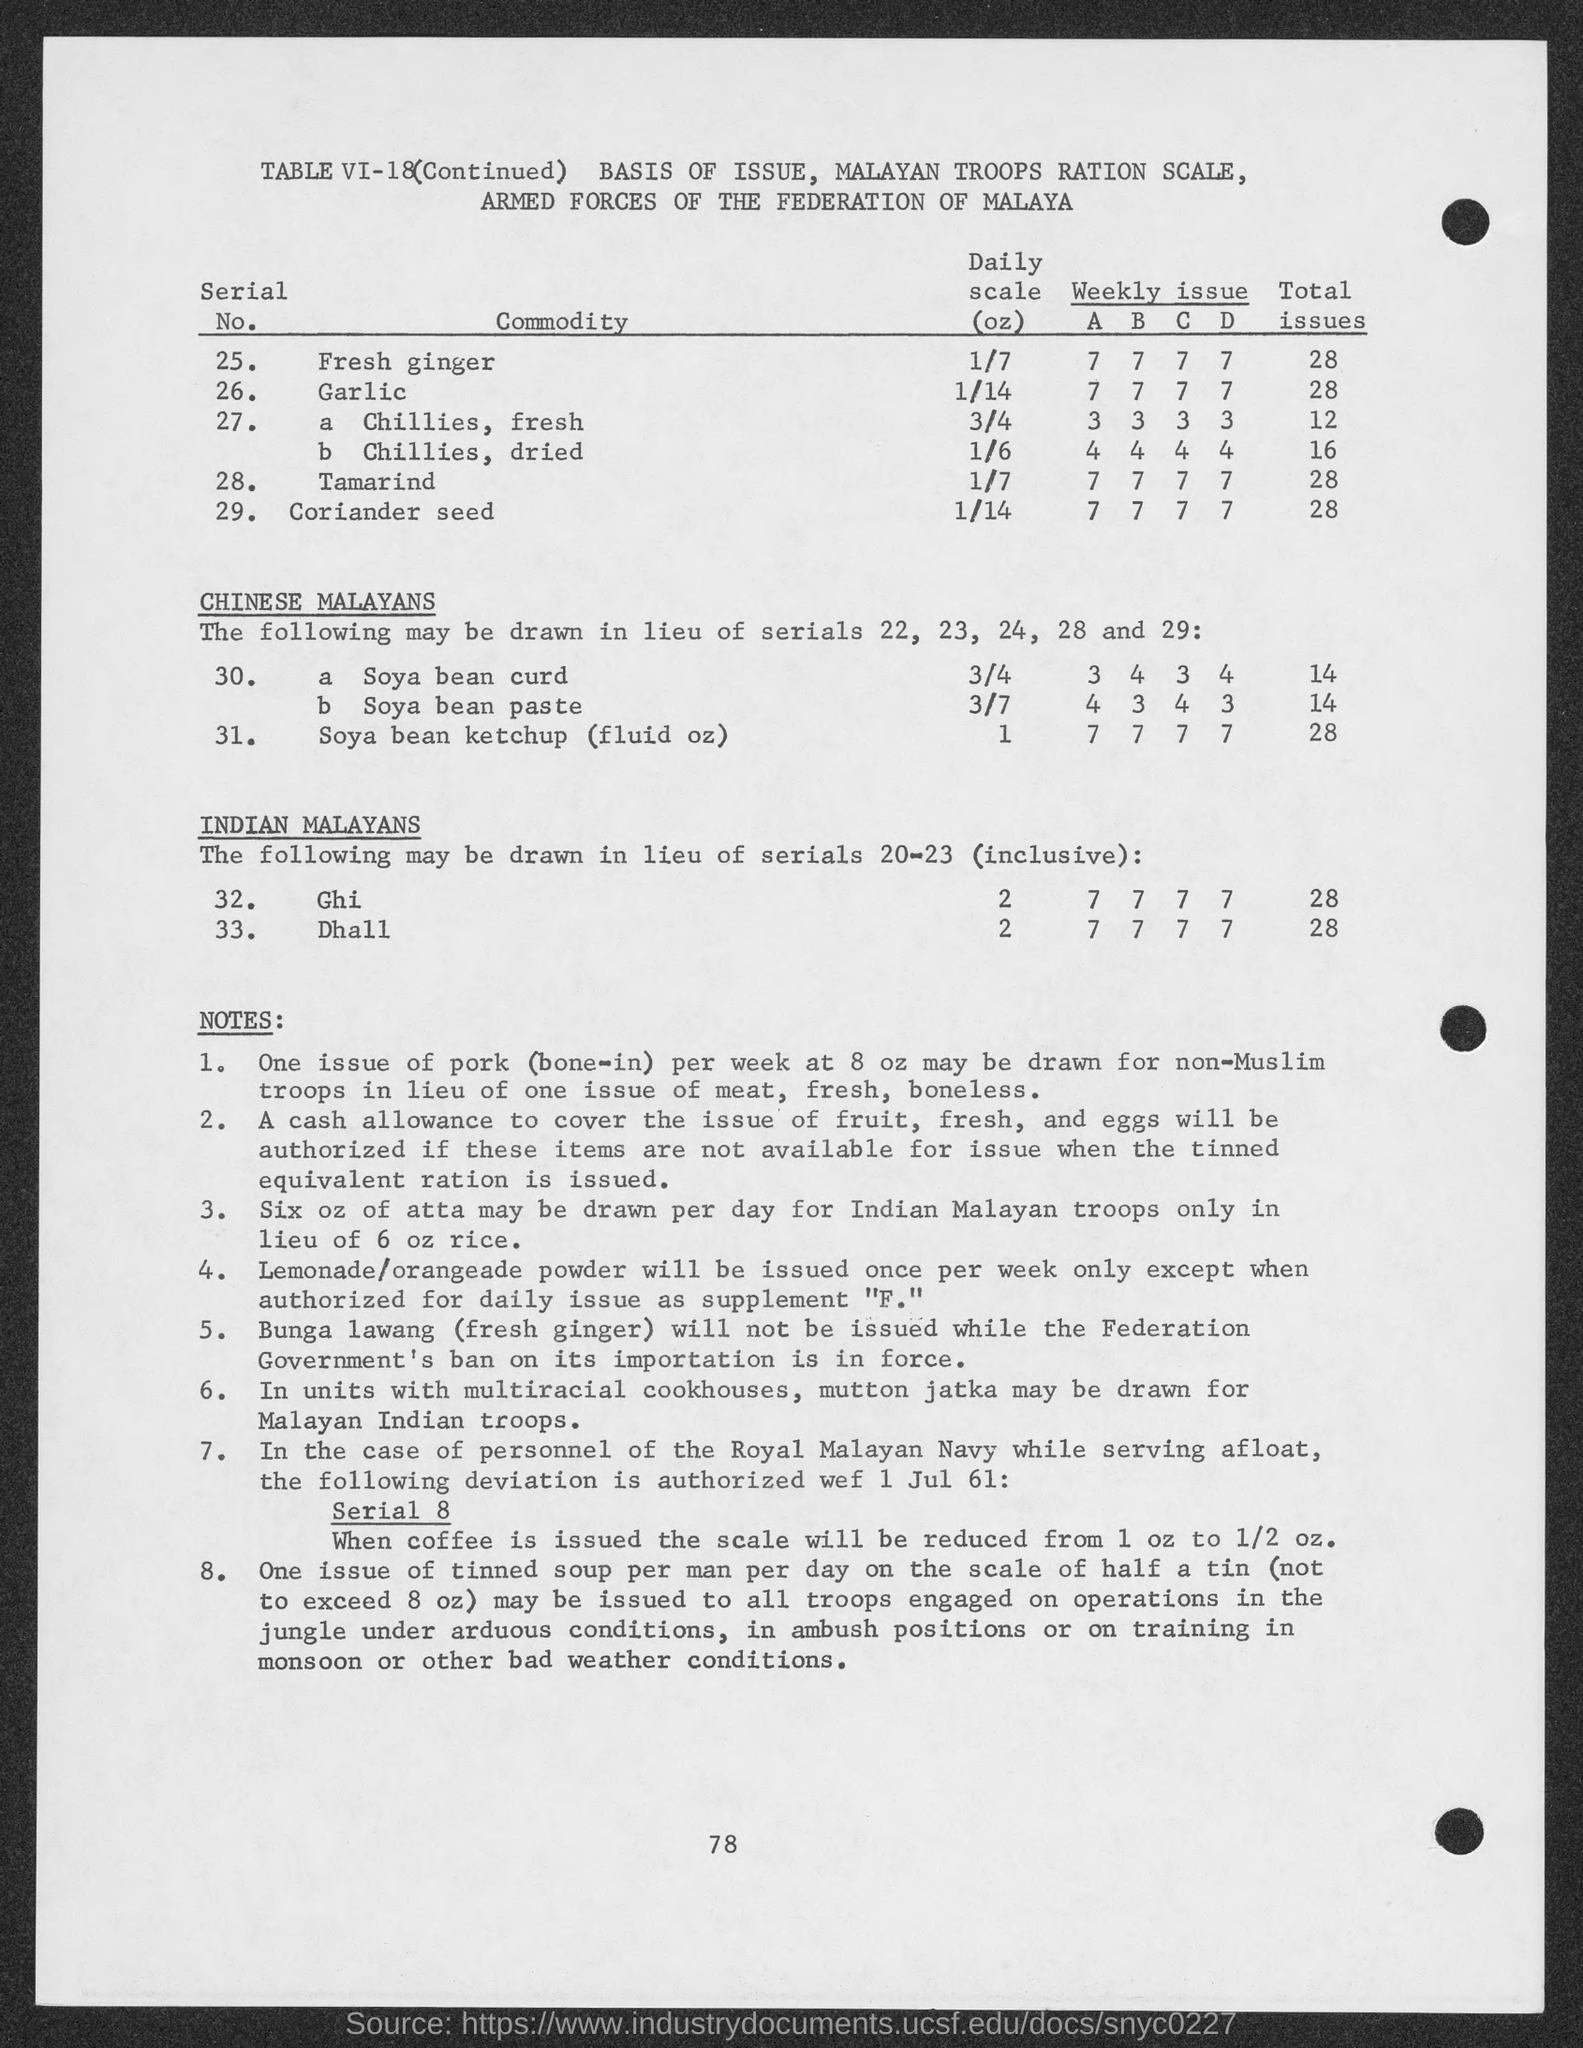Point out several critical features in this image. The value of the total issues of coriander seed is 28. The value of the daily scale of GHI is 2. The value of total issues for Tamarind is 28. The numerical value of "serial no." of garlic is 26. The heading of the second column of the table is 'Commodity.' 